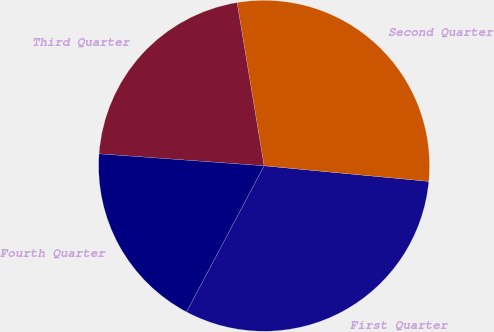Convert chart. <chart><loc_0><loc_0><loc_500><loc_500><pie_chart><fcel>First Quarter<fcel>Second Quarter<fcel>Third Quarter<fcel>Fourth Quarter<nl><fcel>31.27%<fcel>29.11%<fcel>21.24%<fcel>18.39%<nl></chart> 